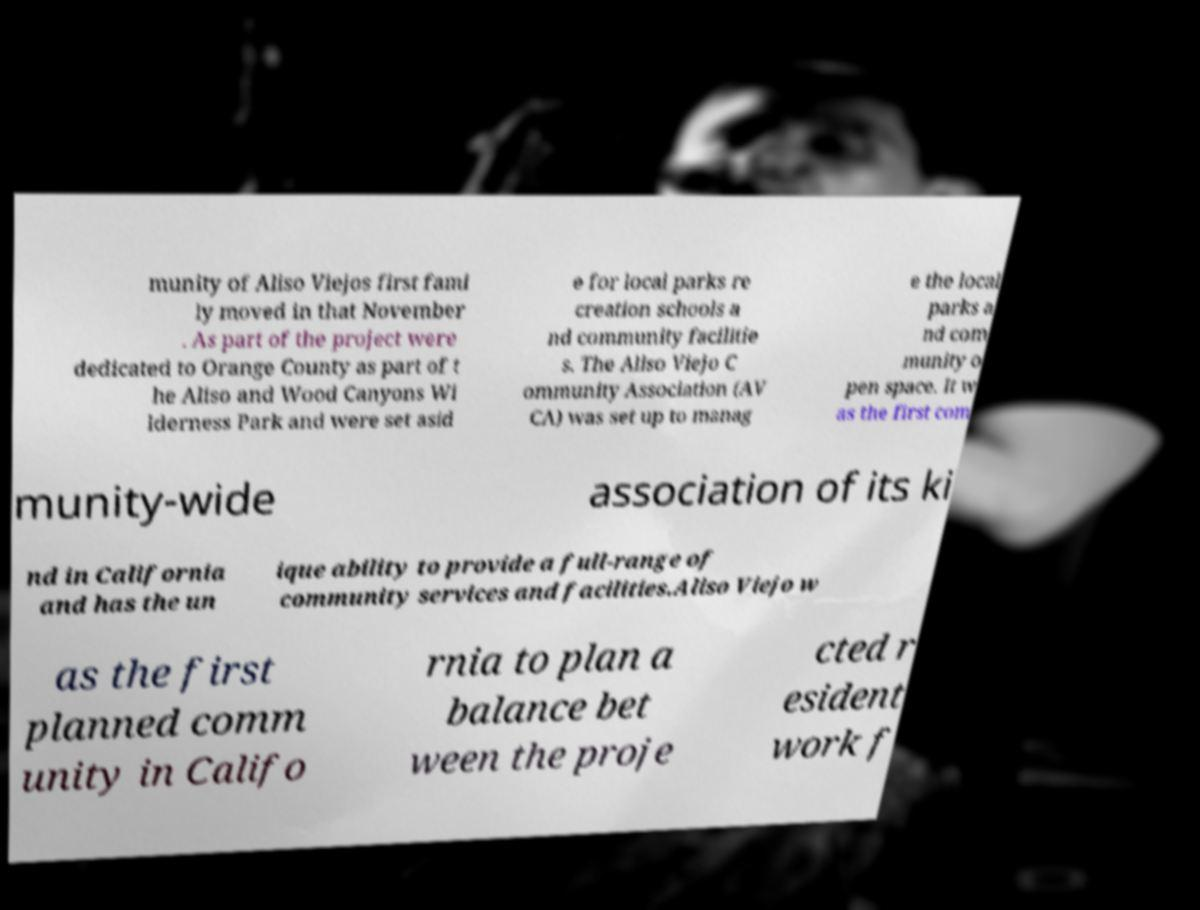Can you read and provide the text displayed in the image?This photo seems to have some interesting text. Can you extract and type it out for me? munity of Aliso Viejos first fami ly moved in that November . As part of the project were dedicated to Orange County as part of t he Aliso and Wood Canyons Wi lderness Park and were set asid e for local parks re creation schools a nd community facilitie s. The Aliso Viejo C ommunity Association (AV CA) was set up to manag e the local parks a nd com munity o pen space. It w as the first com munity-wide association of its ki nd in California and has the un ique ability to provide a full-range of community services and facilities.Aliso Viejo w as the first planned comm unity in Califo rnia to plan a balance bet ween the proje cted r esident work f 